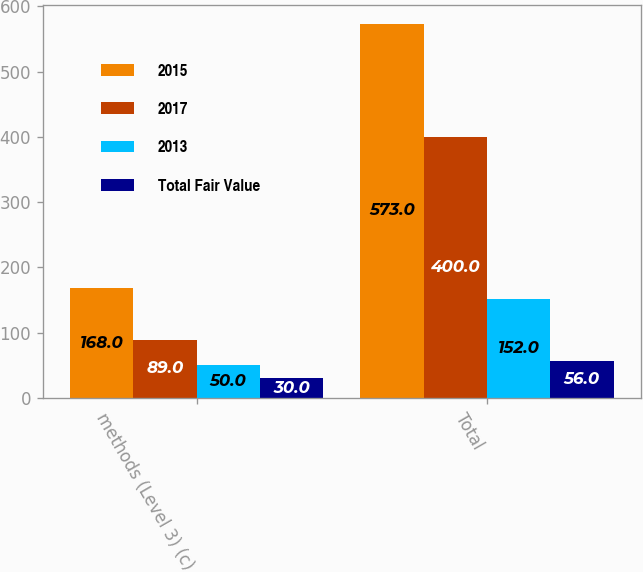<chart> <loc_0><loc_0><loc_500><loc_500><stacked_bar_chart><ecel><fcel>methods (Level 3) (c)<fcel>Total<nl><fcel>2015<fcel>168<fcel>573<nl><fcel>2017<fcel>89<fcel>400<nl><fcel>2013<fcel>50<fcel>152<nl><fcel>Total Fair Value<fcel>30<fcel>56<nl></chart> 